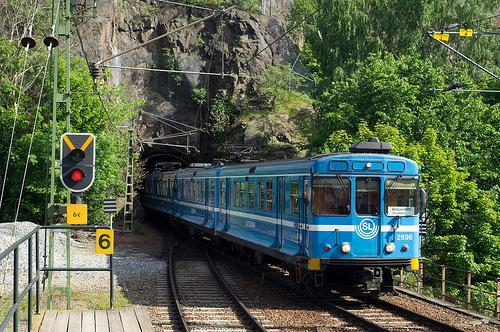Question: where is this scene?
Choices:
A. Railway.
B. Farm.
C. Zoo.
D. Beach.
Answer with the letter. Answer: A Question: what is cast?
Choices:
A. Shadow.
B. Actor.
C. Role.
D. Singer.
Answer with the letter. Answer: A 